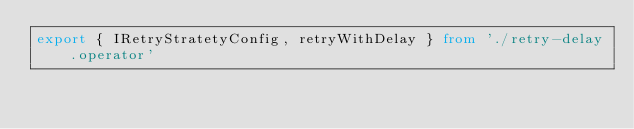Convert code to text. <code><loc_0><loc_0><loc_500><loc_500><_TypeScript_>export { IRetryStratetyConfig, retryWithDelay } from './retry-delay.operator'</code> 